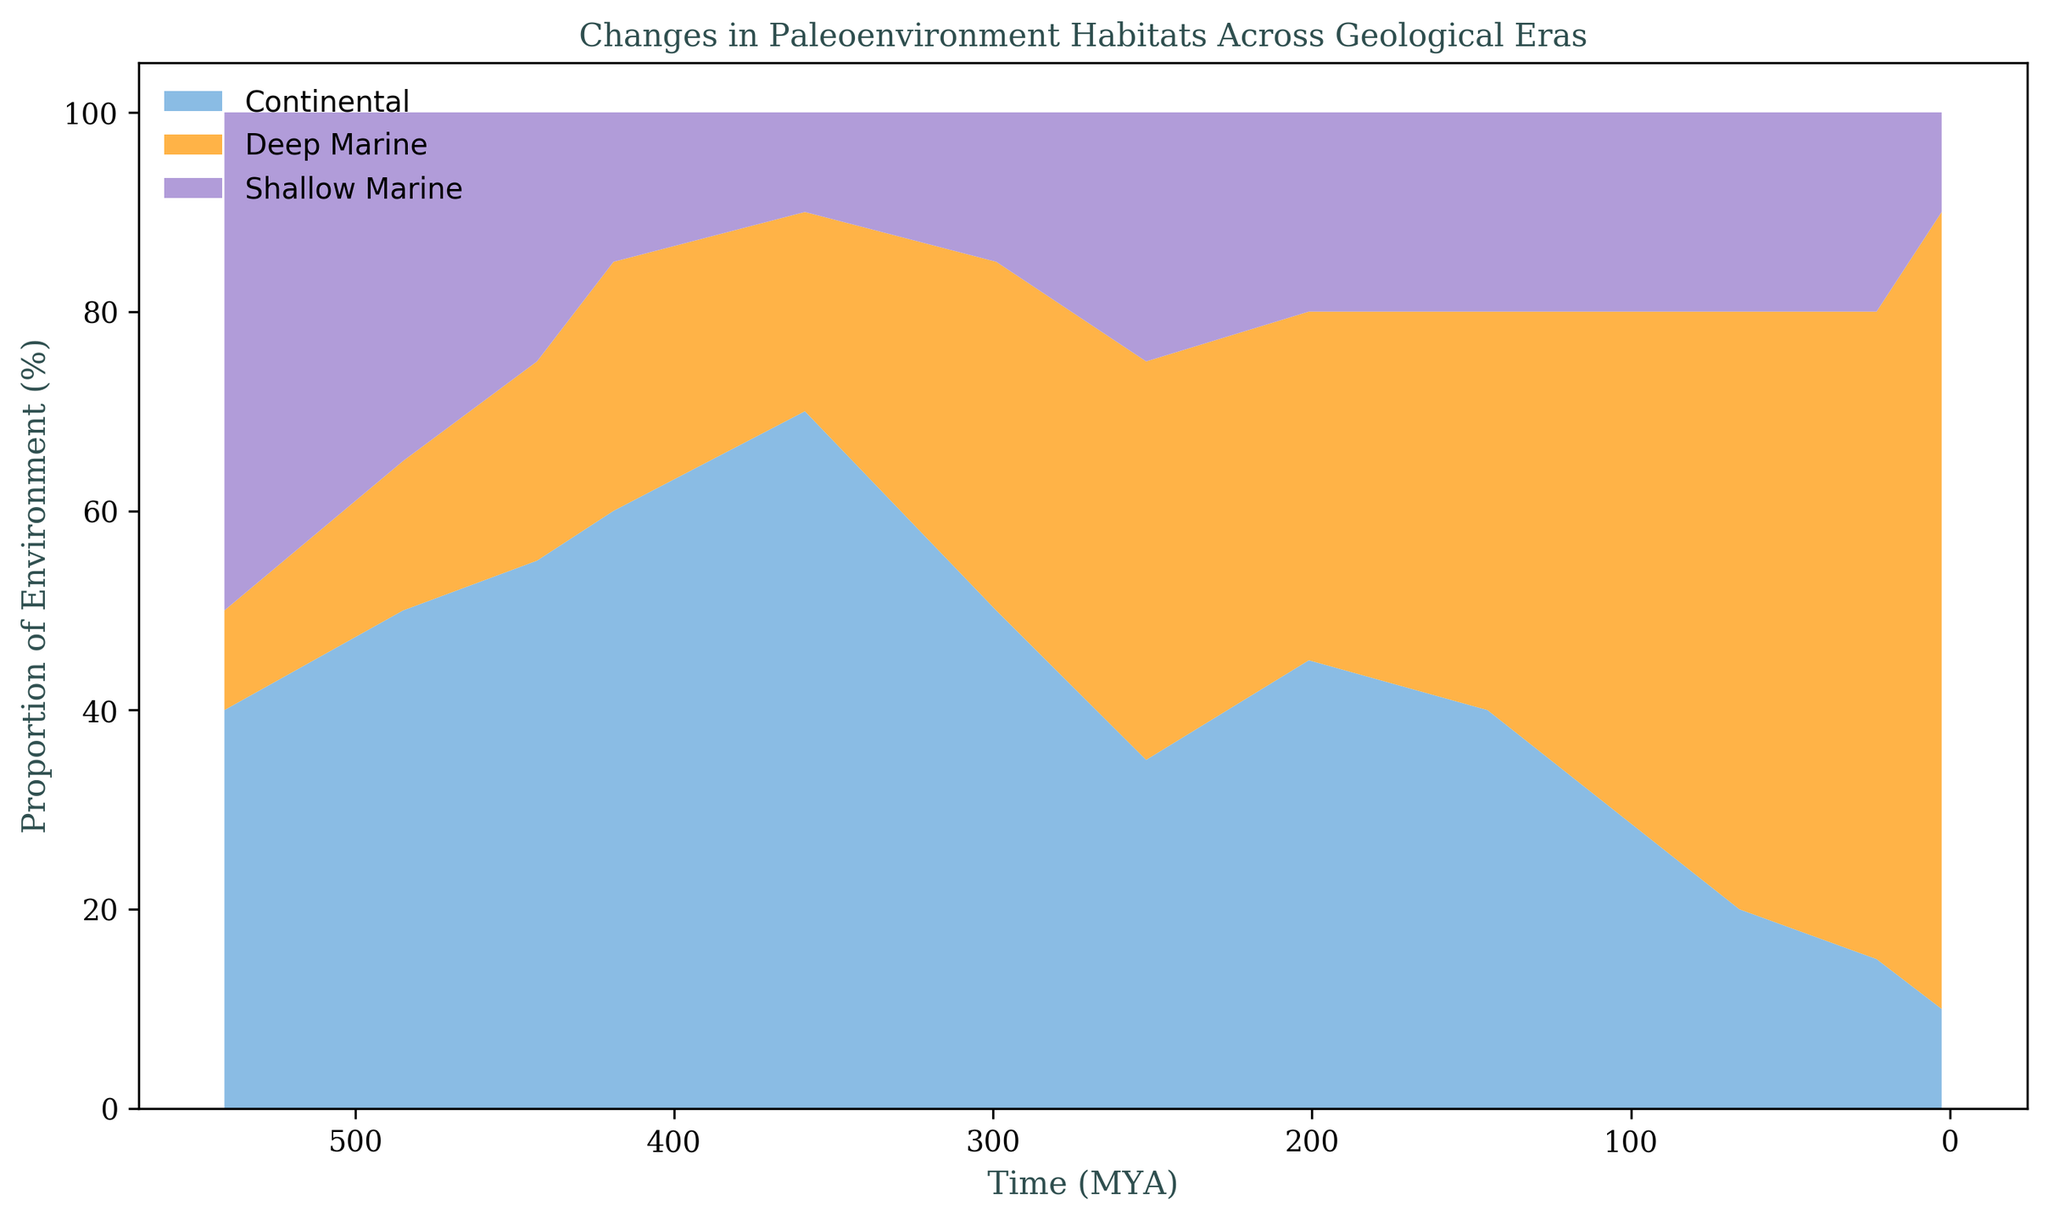What era shows the highest proportion of Continental habitats? To determine this, observe the area chart and look for the portion representing Continental habitats. The Continental habitat is color-coded and spans across different eras. Notably, the Cenozoic era has the highest proportion of Continental habitats.
Answer: Cenozoic Which period in the Paleozoic era has the largest proportion of Deep Marine habitats? Examine the area corresponding to Deep Marine habitats within the Paleozoic era. It's indicated by the colored section for Deep Marine across different periods. The Cambrian period within Paleozoic has the largest proportion of Deep Marine habitats.
Answer: Cambrian In which period did Shallow Marine habitats reach their peak during the Paleozoic era? Inspect the area chart and identify the highest point of Shallow Marine habitats within the Paleozoic era. Shallow Marine habitats peak during the Carboniferous period in the Paleozoic era.
Answer: Carboniferous What is the average proportion of Continental habitats in the Mesozoic era? To find the average proportion, identify the proportion values for Continental habitats across all periods in the Mesozoic era (Triassic: 40%, Jurassic: 35%, Cretaceous: 40%). Sum these values and divide by the number of periods. (40 + 35 + 40) / 3 = 115 / 3 = 38.3%.
Answer: 38.3% Compare the proportion of Shallow Marine habitats between the Paleogene and Neogene periods. Which one has a higher proportion? Look at the specific sections representing Shallow Marine habitats. In the Paleogene period, the proportion is 20%, while in the Neogene period, it is 15%. Therefore, the Paleogene period has a higher proportion of Shallow Marine habitats.
Answer: Paleogene What is the difference in the proportion of Continental habitats between the Neogene and Quaternary periods? Determine the proportions of Continental habitats in both periods (Neogene: 65%, Quaternary: 80%). Subtract the smaller proportion from the larger one. 80 - 65 = 15.
Answer: 15 During which period did the proportion of Shallow Marine habitats decrease significantly transitioning from Paleozoic to Mesozoic era? Identify the period just before and into the transition. The transition is from the Permian (Paleozoic) to the Triassic (Mesozoic). In the Permian period, Shallow Marine habitats were 50%, and in the Triassic period, it dropped to 35%.
Answer: Triassic What's the combined proportion of Continental and Deep Marine habitats in the Ordovician period? Sum the proportions of Continental and Deep Marine habitats in the Ordovician period (Continental: 15%, Deep Marine: 35%). (15 + 35) = 50%.
Answer: 50% Is the proportion of Continental habitats in the Cambrian period lower or higher than in the Quaternary period? Compare the proportion values directly from the chart. In the Cambrian period, the proportion is 10%, and in the Quaternary period, it is 80%. The proportion in the Cambrian period is lower.
Answer: Lower In which era do Shallow Marine habitats consistently occupy a smaller proportion compared to Continental habitats? Notice the proportions of Shallow Marine and Continental habitats across different eras. In the Cenozoic era, Shallow Marine habitats consistently occupy a smaller proportion compared to Continental habitats.
Answer: Cenozoic 